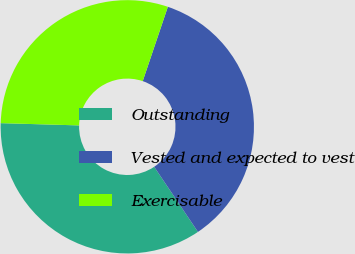Convert chart to OTSL. <chart><loc_0><loc_0><loc_500><loc_500><pie_chart><fcel>Outstanding<fcel>Vested and expected to vest<fcel>Exercisable<nl><fcel>34.88%<fcel>35.39%<fcel>29.73%<nl></chart> 